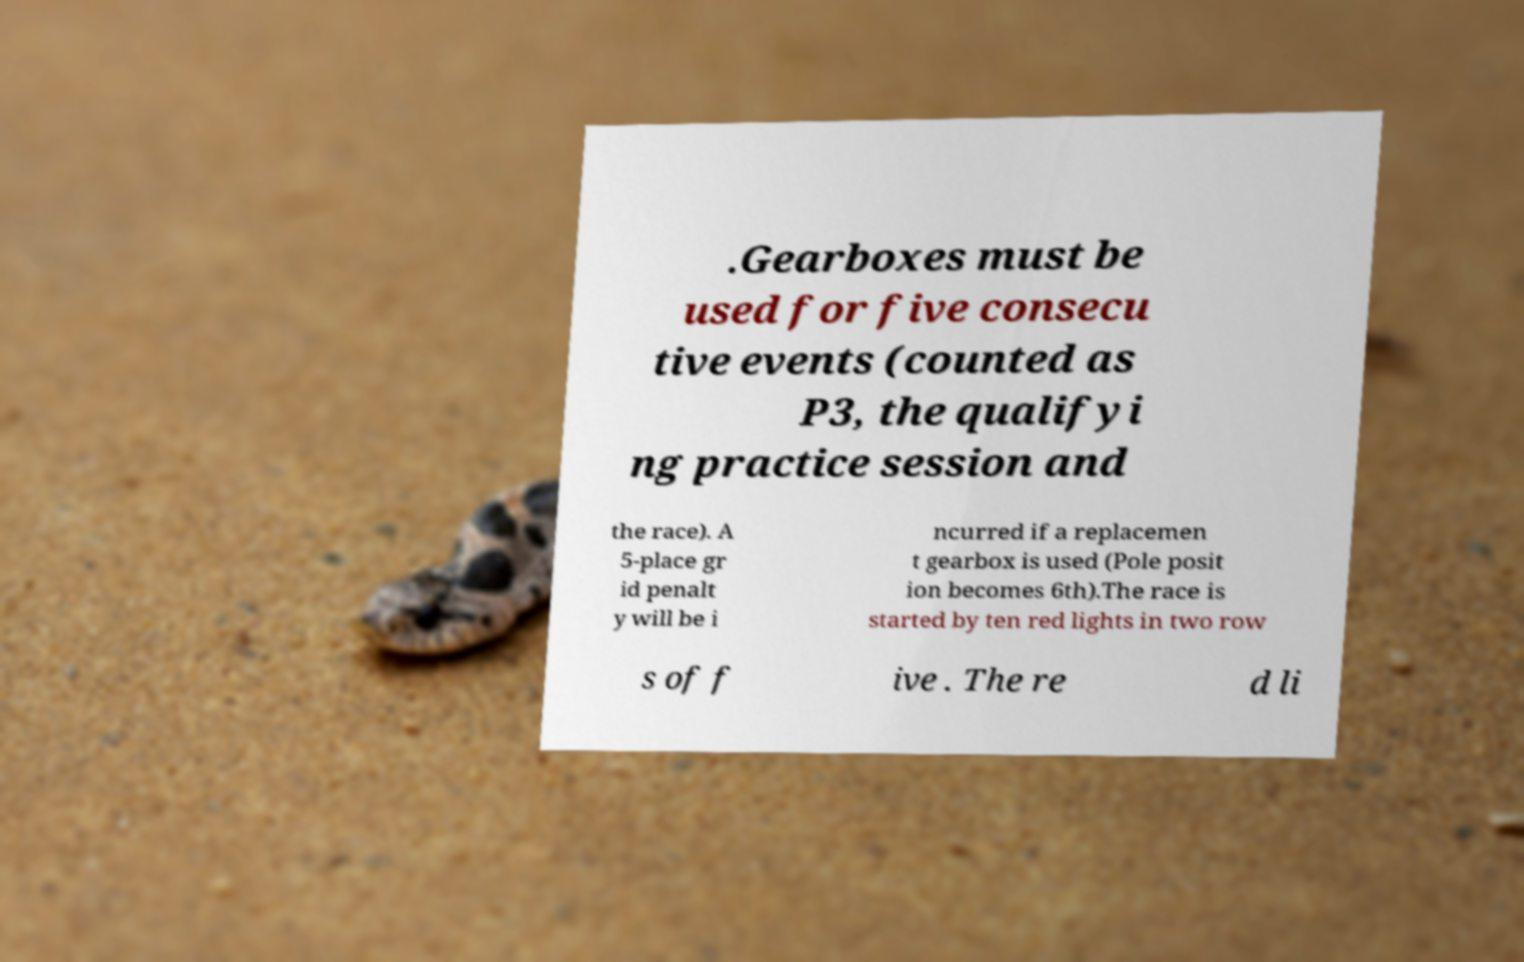What messages or text are displayed in this image? I need them in a readable, typed format. .Gearboxes must be used for five consecu tive events (counted as P3, the qualifyi ng practice session and the race). A 5-place gr id penalt y will be i ncurred if a replacemen t gearbox is used (Pole posit ion becomes 6th).The race is started by ten red lights in two row s of f ive . The re d li 